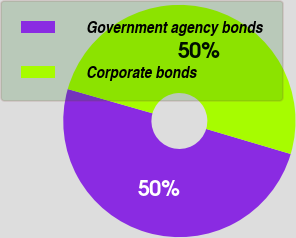<chart> <loc_0><loc_0><loc_500><loc_500><pie_chart><fcel>Government agency bonds<fcel>Corporate bonds<nl><fcel>49.85%<fcel>50.15%<nl></chart> 